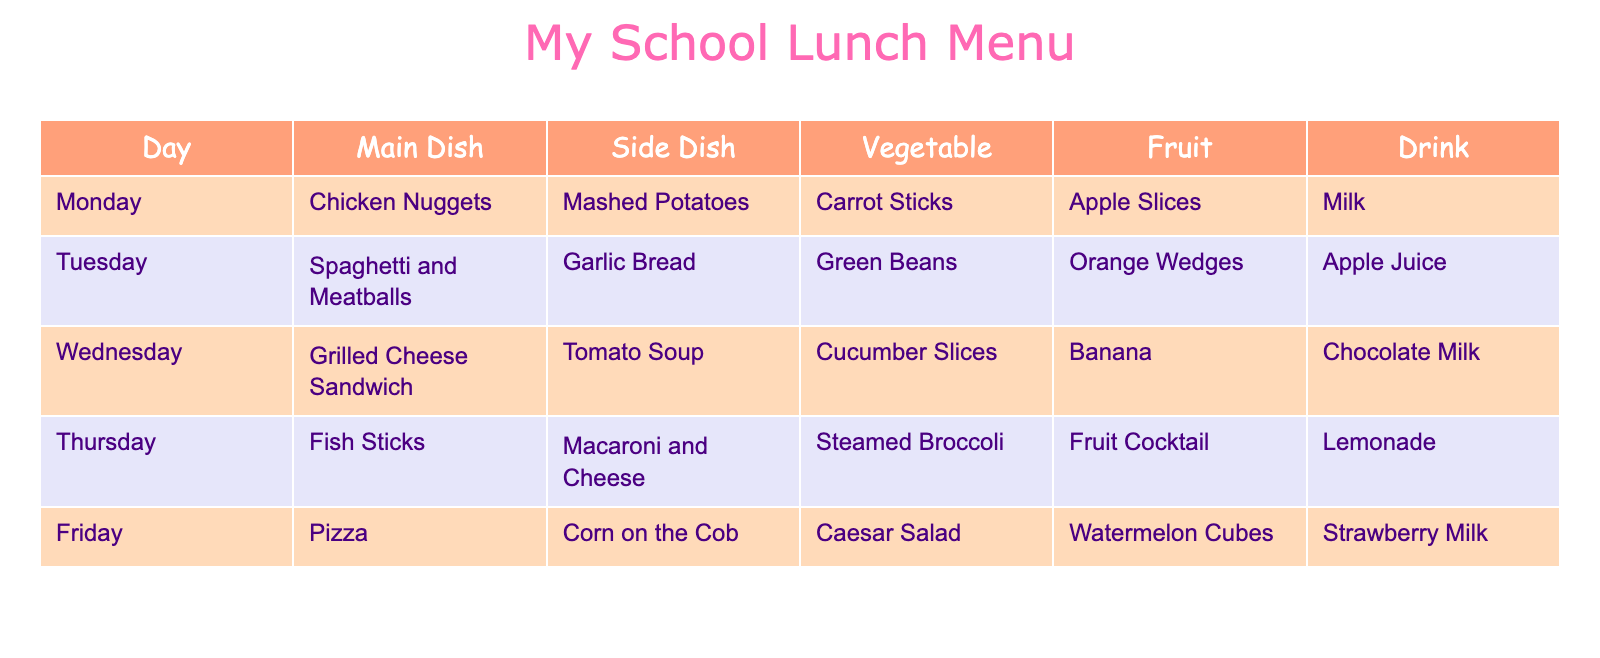What is the main dish served on Wednesday? You can look at the row for Wednesday in the table, which shows that the main dish is "Grilled Cheese Sandwich."
Answer: Grilled Cheese Sandwich How many days have fish as the main dish? By checking the main dish column in the table, Fish Sticks is listed under Thursday only, indicating that there is one day with fish as the main dish.
Answer: 1 What drink is served with the pizza? Looking at the row for Friday, the drink option is "Strawberry Milk."
Answer: Strawberry Milk On which day is the side dish "Garlic Bread" served? You can see that "Garlic Bread" is listed under Tuesday, making that the day it is served.
Answer: Tuesday Which fruit is served with the grilled cheese sandwich? Referring to Wednesday's row, the fruit listed is "Banana."
Answer: Banana What is the average number of different side dishes served per day? There are 5 days, and each day has 1 unique side dish, meaning the average is 5 different side dishes divided by 5 days, which equals 1.
Answer: 1 Is "Macaroni and Cheese" served as a vegetable? "Macaroni and Cheese" is listed as a side dish on Thursday, not a vegetable, so the answer is no.
Answer: No On what day is the combination of "Corn on the Cob" and "Caesar Salad" served? This combination is found on Friday according to the table. Therefore, Friday is the day when both dishes are served together.
Answer: Friday How many different types of fruits are served throughout the week? Looking at the fruit column, the types listed are: "Apple Slices," "Orange Wedges," "Banana," "Fruit Cocktail," and "Watermelon Cubes." This counts to 5 different types of fruits served in total.
Answer: 5 